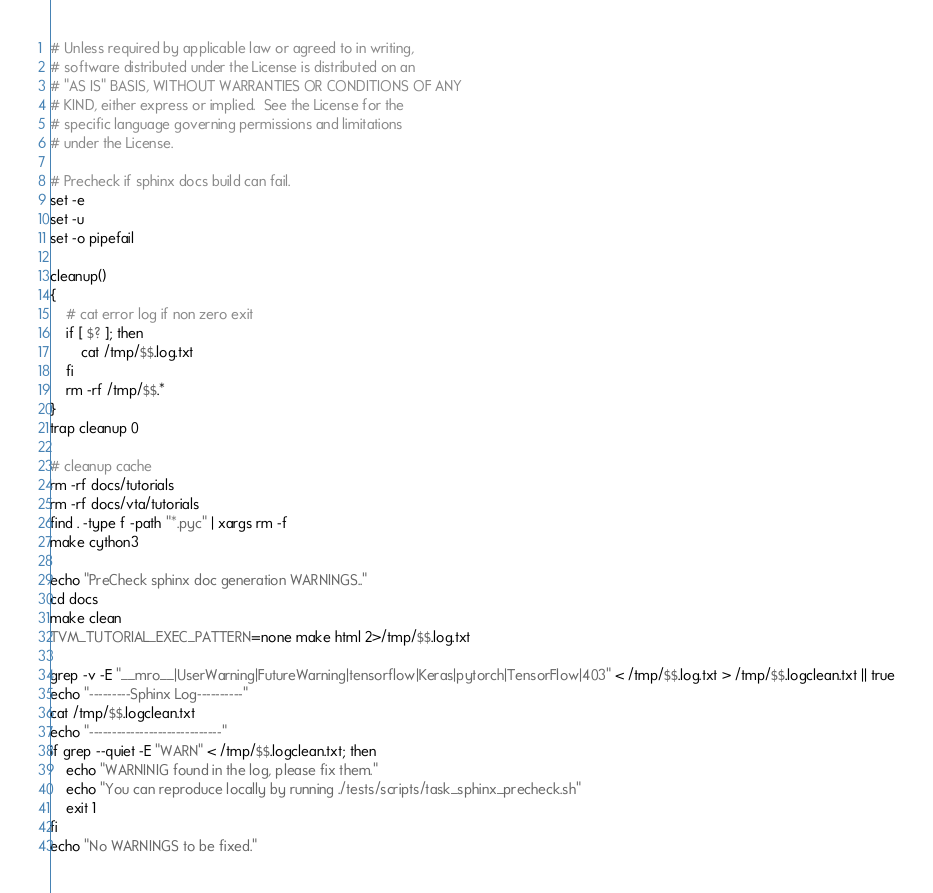Convert code to text. <code><loc_0><loc_0><loc_500><loc_500><_Bash_># Unless required by applicable law or agreed to in writing,
# software distributed under the License is distributed on an
# "AS IS" BASIS, WITHOUT WARRANTIES OR CONDITIONS OF ANY
# KIND, either express or implied.  See the License for the
# specific language governing permissions and limitations
# under the License.

# Precheck if sphinx docs build can fail.
set -e
set -u
set -o pipefail

cleanup()
{
    # cat error log if non zero exit
    if [ $? ]; then
        cat /tmp/$$.log.txt
    fi
    rm -rf /tmp/$$.*
}
trap cleanup 0

# cleanup cache
rm -rf docs/tutorials
rm -rf docs/vta/tutorials
find . -type f -path "*.pyc" | xargs rm -f
make cython3

echo "PreCheck sphinx doc generation WARNINGS.."
cd docs
make clean
TVM_TUTORIAL_EXEC_PATTERN=none make html 2>/tmp/$$.log.txt

grep -v -E "__mro__|UserWarning|FutureWarning|tensorflow|Keras|pytorch|TensorFlow|403" < /tmp/$$.log.txt > /tmp/$$.logclean.txt || true
echo "---------Sphinx Log----------"
cat /tmp/$$.logclean.txt
echo "-----------------------------"
if grep --quiet -E "WARN" < /tmp/$$.logclean.txt; then
    echo "WARNINIG found in the log, please fix them."
    echo "You can reproduce locally by running ./tests/scripts/task_sphinx_precheck.sh"
    exit 1
fi
echo "No WARNINGS to be fixed."
</code> 